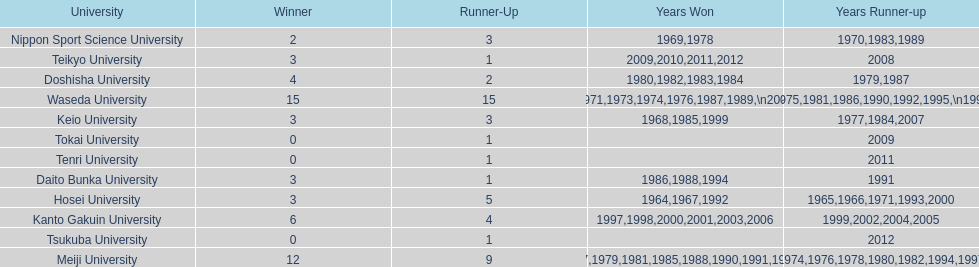How many championships does nippon sport science university have 2. 